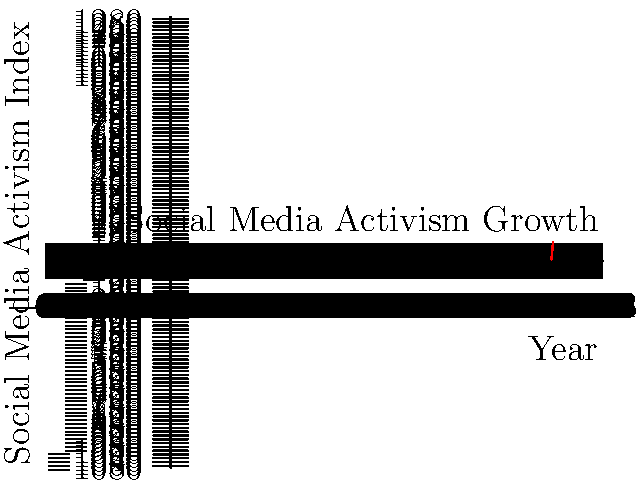Based on the line graph depicting the growth of social media activism from 2010 to 2020, during which two-year period did the steepest increase in activism occur? How might this rapid growth have influenced policy-making processes, and what challenges could it present for policy analysts in translating this surge of online activism into actionable policies? To answer this question, we need to follow these steps:

1. Analyze the graph to identify the steepest increase:
   - Calculate the slope between each pair of consecutive points.
   - The steepest increase corresponds to the highest slope.

2. Slopes for each period:
   - 2010-2012: $\frac{25-10}{2012-2010} = 7.5$ per year
   - 2012-2014: $\frac{45-25}{2014-2012} = 10$ per year
   - 2014-2016: $\frac{70-45}{2016-2014} = 12.5$ per year
   - 2016-2018: $\frac{85-70}{2018-2016} = 7.5$ per year
   - 2018-2020: $\frac{100-85}{2020-2018} = 7.5$ per year

3. The steepest increase occurred between 2014 and 2016.

4. Implications for policy-making processes:
   - Rapid influx of diverse opinions and demands
   - Increased pressure on policymakers to respond quickly
   - Potential for viral campaigns to influence policy agendas

5. Challenges for policy analysts:
   - Distinguishing between trending topics and substantive issues
   - Analyzing the representativeness of online activism
   - Translating viral hashtags into concrete policy proposals
   - Balancing rapid response with thorough policy analysis
   - Addressing the digital divide in policy considerations

6. Strategies for translating online activism into actionable policies:
   - Develop robust social media monitoring tools
   - Engage with online communities to understand underlying concerns
   - Collaborate with digital influencers and grassroots organizations
   - Create frameworks for assessing the impact and reach of online movements
   - Establish mechanisms for rapid policy prototyping and feedback loops
Answer: 2014-2016; Rapid growth challenges policy analysts to balance swift response with thorough analysis, requiring new strategies to translate viral campaigns into substantive, actionable policies while considering digital divide issues. 